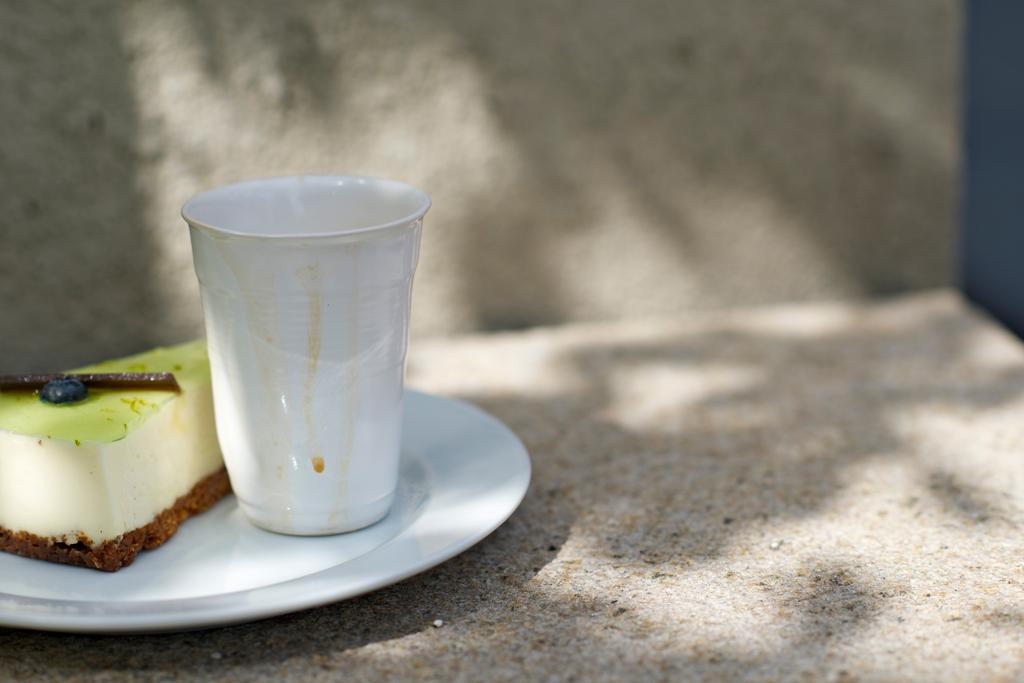What type of dessert is visible in the image? There is a piece of cake in the image. What is the other object visible in the image? There is a glass in the image. How is the glass positioned in relation to the cake? The glass is on a plate in the image. Where is the plate located? The plate is on a concrete wall in the image. Can you see any veins in the cake in the image? There are no veins visible in the cake in the image, as veins are not a characteristic of cake. 